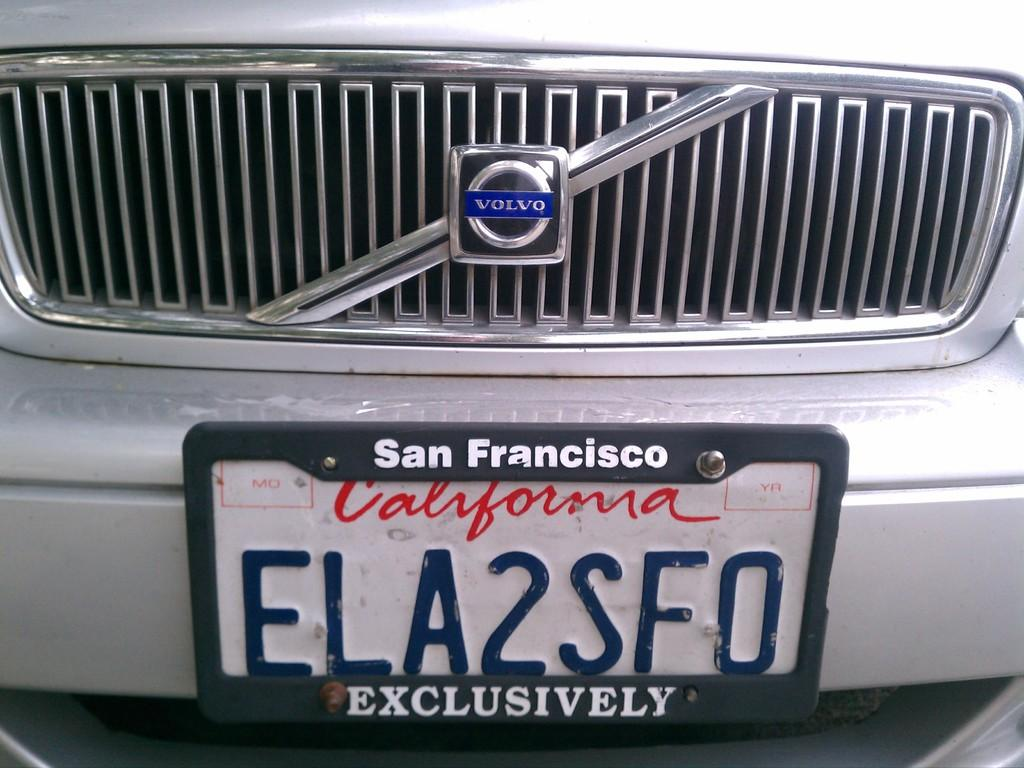<image>
Present a compact description of the photo's key features. A close up is shown of the license plate "ELA2SFO" on a Volvo. 